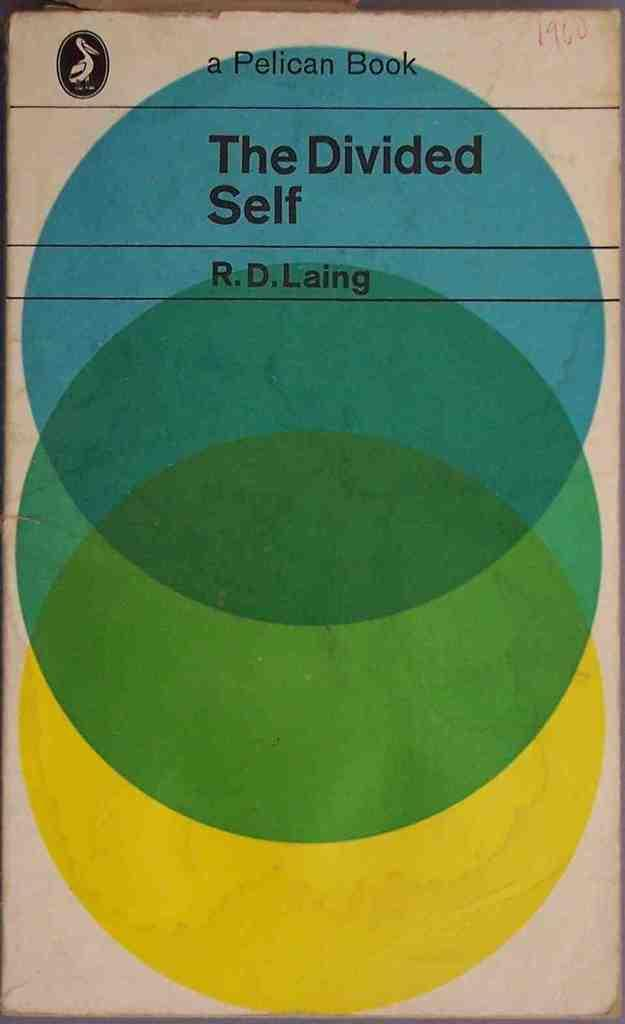<image>
Describe the image concisely. A book cover titled The Divided Self a Pelican Book. 